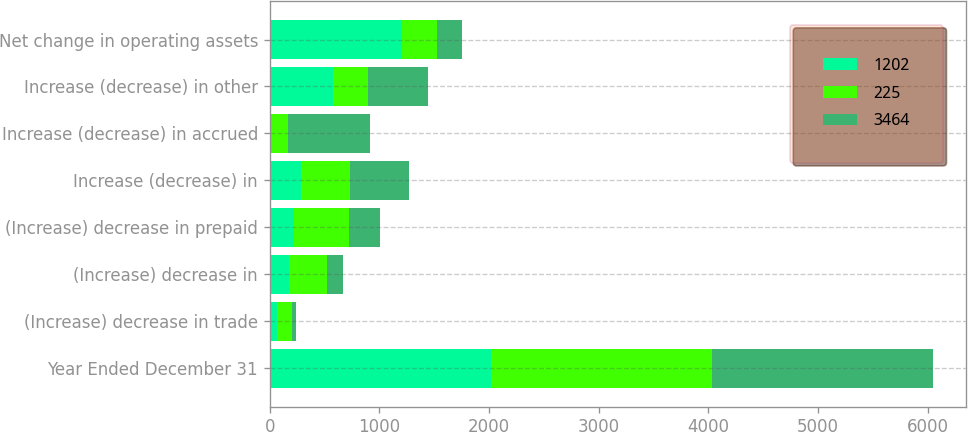Convert chart. <chart><loc_0><loc_0><loc_500><loc_500><stacked_bar_chart><ecel><fcel>Year Ended December 31<fcel>(Increase) decrease in trade<fcel>(Increase) decrease in<fcel>(Increase) decrease in prepaid<fcel>Increase (decrease) in<fcel>Increase (decrease) in accrued<fcel>Increase (decrease) in other<fcel>Net change in operating assets<nl><fcel>1202<fcel>2018<fcel>66<fcel>171<fcel>221<fcel>289<fcel>12<fcel>575<fcel>1202<nl><fcel>225<fcel>2017<fcel>141<fcel>355<fcel>506<fcel>445<fcel>153<fcel>322<fcel>322<nl><fcel>3464<fcel>2016<fcel>28<fcel>142<fcel>279<fcel>540<fcel>750<fcel>544<fcel>225<nl></chart> 